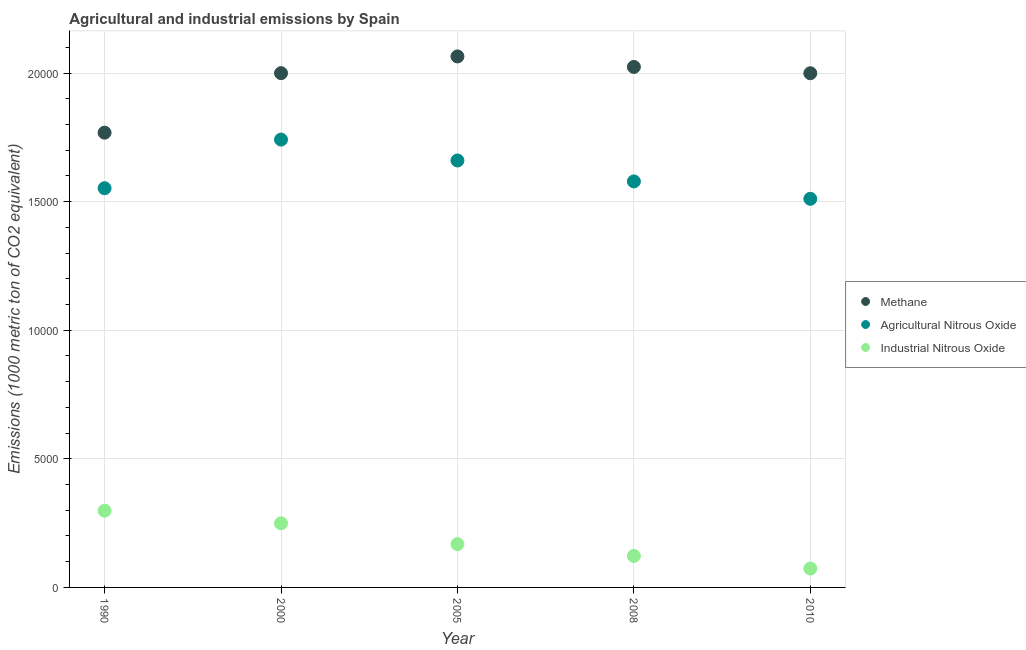How many different coloured dotlines are there?
Your answer should be compact. 3. Is the number of dotlines equal to the number of legend labels?
Your response must be concise. Yes. What is the amount of methane emissions in 2000?
Offer a very short reply. 2.00e+04. Across all years, what is the maximum amount of industrial nitrous oxide emissions?
Make the answer very short. 2982.4. Across all years, what is the minimum amount of agricultural nitrous oxide emissions?
Provide a short and direct response. 1.51e+04. In which year was the amount of agricultural nitrous oxide emissions maximum?
Provide a short and direct response. 2000. What is the total amount of methane emissions in the graph?
Your answer should be compact. 9.86e+04. What is the difference between the amount of agricultural nitrous oxide emissions in 2005 and that in 2010?
Ensure brevity in your answer.  1490. What is the difference between the amount of methane emissions in 2010 and the amount of industrial nitrous oxide emissions in 2008?
Offer a very short reply. 1.88e+04. What is the average amount of agricultural nitrous oxide emissions per year?
Keep it short and to the point. 1.61e+04. In the year 2010, what is the difference between the amount of agricultural nitrous oxide emissions and amount of industrial nitrous oxide emissions?
Provide a succinct answer. 1.44e+04. In how many years, is the amount of agricultural nitrous oxide emissions greater than 10000 metric ton?
Your answer should be compact. 5. What is the ratio of the amount of agricultural nitrous oxide emissions in 2000 to that in 2005?
Provide a succinct answer. 1.05. Is the difference between the amount of agricultural nitrous oxide emissions in 2008 and 2010 greater than the difference between the amount of industrial nitrous oxide emissions in 2008 and 2010?
Provide a short and direct response. Yes. What is the difference between the highest and the second highest amount of methane emissions?
Offer a terse response. 408.9. What is the difference between the highest and the lowest amount of agricultural nitrous oxide emissions?
Ensure brevity in your answer.  2302.5. Does the amount of agricultural nitrous oxide emissions monotonically increase over the years?
Offer a very short reply. No. Is the amount of agricultural nitrous oxide emissions strictly less than the amount of industrial nitrous oxide emissions over the years?
Your answer should be very brief. No. How many dotlines are there?
Give a very brief answer. 3. What is the difference between two consecutive major ticks on the Y-axis?
Offer a terse response. 5000. Are the values on the major ticks of Y-axis written in scientific E-notation?
Make the answer very short. No. Does the graph contain grids?
Give a very brief answer. Yes. How many legend labels are there?
Offer a very short reply. 3. How are the legend labels stacked?
Give a very brief answer. Vertical. What is the title of the graph?
Your response must be concise. Agricultural and industrial emissions by Spain. What is the label or title of the X-axis?
Your answer should be very brief. Year. What is the label or title of the Y-axis?
Your answer should be compact. Emissions (1000 metric ton of CO2 equivalent). What is the Emissions (1000 metric ton of CO2 equivalent) in Methane in 1990?
Your answer should be very brief. 1.77e+04. What is the Emissions (1000 metric ton of CO2 equivalent) of Agricultural Nitrous Oxide in 1990?
Make the answer very short. 1.55e+04. What is the Emissions (1000 metric ton of CO2 equivalent) in Industrial Nitrous Oxide in 1990?
Make the answer very short. 2982.4. What is the Emissions (1000 metric ton of CO2 equivalent) of Methane in 2000?
Your response must be concise. 2.00e+04. What is the Emissions (1000 metric ton of CO2 equivalent) of Agricultural Nitrous Oxide in 2000?
Your answer should be compact. 1.74e+04. What is the Emissions (1000 metric ton of CO2 equivalent) in Industrial Nitrous Oxide in 2000?
Provide a succinct answer. 2493. What is the Emissions (1000 metric ton of CO2 equivalent) in Methane in 2005?
Your answer should be very brief. 2.06e+04. What is the Emissions (1000 metric ton of CO2 equivalent) of Agricultural Nitrous Oxide in 2005?
Offer a terse response. 1.66e+04. What is the Emissions (1000 metric ton of CO2 equivalent) in Industrial Nitrous Oxide in 2005?
Keep it short and to the point. 1685.1. What is the Emissions (1000 metric ton of CO2 equivalent) of Methane in 2008?
Provide a short and direct response. 2.02e+04. What is the Emissions (1000 metric ton of CO2 equivalent) in Agricultural Nitrous Oxide in 2008?
Your answer should be compact. 1.58e+04. What is the Emissions (1000 metric ton of CO2 equivalent) of Industrial Nitrous Oxide in 2008?
Offer a very short reply. 1224.9. What is the Emissions (1000 metric ton of CO2 equivalent) in Methane in 2010?
Give a very brief answer. 2.00e+04. What is the Emissions (1000 metric ton of CO2 equivalent) in Agricultural Nitrous Oxide in 2010?
Give a very brief answer. 1.51e+04. What is the Emissions (1000 metric ton of CO2 equivalent) in Industrial Nitrous Oxide in 2010?
Your answer should be very brief. 734.8. Across all years, what is the maximum Emissions (1000 metric ton of CO2 equivalent) of Methane?
Make the answer very short. 2.06e+04. Across all years, what is the maximum Emissions (1000 metric ton of CO2 equivalent) in Agricultural Nitrous Oxide?
Your answer should be very brief. 1.74e+04. Across all years, what is the maximum Emissions (1000 metric ton of CO2 equivalent) of Industrial Nitrous Oxide?
Provide a succinct answer. 2982.4. Across all years, what is the minimum Emissions (1000 metric ton of CO2 equivalent) of Methane?
Provide a succinct answer. 1.77e+04. Across all years, what is the minimum Emissions (1000 metric ton of CO2 equivalent) in Agricultural Nitrous Oxide?
Provide a succinct answer. 1.51e+04. Across all years, what is the minimum Emissions (1000 metric ton of CO2 equivalent) of Industrial Nitrous Oxide?
Offer a terse response. 734.8. What is the total Emissions (1000 metric ton of CO2 equivalent) of Methane in the graph?
Ensure brevity in your answer.  9.86e+04. What is the total Emissions (1000 metric ton of CO2 equivalent) in Agricultural Nitrous Oxide in the graph?
Your answer should be compact. 8.04e+04. What is the total Emissions (1000 metric ton of CO2 equivalent) of Industrial Nitrous Oxide in the graph?
Your answer should be compact. 9120.2. What is the difference between the Emissions (1000 metric ton of CO2 equivalent) in Methane in 1990 and that in 2000?
Make the answer very short. -2314.1. What is the difference between the Emissions (1000 metric ton of CO2 equivalent) in Agricultural Nitrous Oxide in 1990 and that in 2000?
Make the answer very short. -1890.8. What is the difference between the Emissions (1000 metric ton of CO2 equivalent) in Industrial Nitrous Oxide in 1990 and that in 2000?
Make the answer very short. 489.4. What is the difference between the Emissions (1000 metric ton of CO2 equivalent) of Methane in 1990 and that in 2005?
Provide a succinct answer. -2964.8. What is the difference between the Emissions (1000 metric ton of CO2 equivalent) of Agricultural Nitrous Oxide in 1990 and that in 2005?
Your response must be concise. -1078.3. What is the difference between the Emissions (1000 metric ton of CO2 equivalent) in Industrial Nitrous Oxide in 1990 and that in 2005?
Provide a short and direct response. 1297.3. What is the difference between the Emissions (1000 metric ton of CO2 equivalent) in Methane in 1990 and that in 2008?
Make the answer very short. -2555.9. What is the difference between the Emissions (1000 metric ton of CO2 equivalent) of Agricultural Nitrous Oxide in 1990 and that in 2008?
Your answer should be very brief. -264.1. What is the difference between the Emissions (1000 metric ton of CO2 equivalent) in Industrial Nitrous Oxide in 1990 and that in 2008?
Keep it short and to the point. 1757.5. What is the difference between the Emissions (1000 metric ton of CO2 equivalent) in Methane in 1990 and that in 2010?
Make the answer very short. -2311. What is the difference between the Emissions (1000 metric ton of CO2 equivalent) in Agricultural Nitrous Oxide in 1990 and that in 2010?
Provide a short and direct response. 411.7. What is the difference between the Emissions (1000 metric ton of CO2 equivalent) of Industrial Nitrous Oxide in 1990 and that in 2010?
Offer a terse response. 2247.6. What is the difference between the Emissions (1000 metric ton of CO2 equivalent) of Methane in 2000 and that in 2005?
Keep it short and to the point. -650.7. What is the difference between the Emissions (1000 metric ton of CO2 equivalent) of Agricultural Nitrous Oxide in 2000 and that in 2005?
Offer a very short reply. 812.5. What is the difference between the Emissions (1000 metric ton of CO2 equivalent) in Industrial Nitrous Oxide in 2000 and that in 2005?
Provide a short and direct response. 807.9. What is the difference between the Emissions (1000 metric ton of CO2 equivalent) of Methane in 2000 and that in 2008?
Make the answer very short. -241.8. What is the difference between the Emissions (1000 metric ton of CO2 equivalent) in Agricultural Nitrous Oxide in 2000 and that in 2008?
Ensure brevity in your answer.  1626.7. What is the difference between the Emissions (1000 metric ton of CO2 equivalent) in Industrial Nitrous Oxide in 2000 and that in 2008?
Provide a succinct answer. 1268.1. What is the difference between the Emissions (1000 metric ton of CO2 equivalent) of Agricultural Nitrous Oxide in 2000 and that in 2010?
Offer a terse response. 2302.5. What is the difference between the Emissions (1000 metric ton of CO2 equivalent) of Industrial Nitrous Oxide in 2000 and that in 2010?
Provide a short and direct response. 1758.2. What is the difference between the Emissions (1000 metric ton of CO2 equivalent) of Methane in 2005 and that in 2008?
Your answer should be very brief. 408.9. What is the difference between the Emissions (1000 metric ton of CO2 equivalent) of Agricultural Nitrous Oxide in 2005 and that in 2008?
Ensure brevity in your answer.  814.2. What is the difference between the Emissions (1000 metric ton of CO2 equivalent) in Industrial Nitrous Oxide in 2005 and that in 2008?
Give a very brief answer. 460.2. What is the difference between the Emissions (1000 metric ton of CO2 equivalent) of Methane in 2005 and that in 2010?
Provide a short and direct response. 653.8. What is the difference between the Emissions (1000 metric ton of CO2 equivalent) in Agricultural Nitrous Oxide in 2005 and that in 2010?
Your answer should be compact. 1490. What is the difference between the Emissions (1000 metric ton of CO2 equivalent) of Industrial Nitrous Oxide in 2005 and that in 2010?
Offer a terse response. 950.3. What is the difference between the Emissions (1000 metric ton of CO2 equivalent) in Methane in 2008 and that in 2010?
Provide a short and direct response. 244.9. What is the difference between the Emissions (1000 metric ton of CO2 equivalent) in Agricultural Nitrous Oxide in 2008 and that in 2010?
Make the answer very short. 675.8. What is the difference between the Emissions (1000 metric ton of CO2 equivalent) of Industrial Nitrous Oxide in 2008 and that in 2010?
Ensure brevity in your answer.  490.1. What is the difference between the Emissions (1000 metric ton of CO2 equivalent) in Methane in 1990 and the Emissions (1000 metric ton of CO2 equivalent) in Agricultural Nitrous Oxide in 2000?
Your answer should be very brief. 268.8. What is the difference between the Emissions (1000 metric ton of CO2 equivalent) of Methane in 1990 and the Emissions (1000 metric ton of CO2 equivalent) of Industrial Nitrous Oxide in 2000?
Make the answer very short. 1.52e+04. What is the difference between the Emissions (1000 metric ton of CO2 equivalent) in Agricultural Nitrous Oxide in 1990 and the Emissions (1000 metric ton of CO2 equivalent) in Industrial Nitrous Oxide in 2000?
Provide a succinct answer. 1.30e+04. What is the difference between the Emissions (1000 metric ton of CO2 equivalent) in Methane in 1990 and the Emissions (1000 metric ton of CO2 equivalent) in Agricultural Nitrous Oxide in 2005?
Your response must be concise. 1081.3. What is the difference between the Emissions (1000 metric ton of CO2 equivalent) in Methane in 1990 and the Emissions (1000 metric ton of CO2 equivalent) in Industrial Nitrous Oxide in 2005?
Ensure brevity in your answer.  1.60e+04. What is the difference between the Emissions (1000 metric ton of CO2 equivalent) in Agricultural Nitrous Oxide in 1990 and the Emissions (1000 metric ton of CO2 equivalent) in Industrial Nitrous Oxide in 2005?
Keep it short and to the point. 1.38e+04. What is the difference between the Emissions (1000 metric ton of CO2 equivalent) in Methane in 1990 and the Emissions (1000 metric ton of CO2 equivalent) in Agricultural Nitrous Oxide in 2008?
Offer a terse response. 1895.5. What is the difference between the Emissions (1000 metric ton of CO2 equivalent) of Methane in 1990 and the Emissions (1000 metric ton of CO2 equivalent) of Industrial Nitrous Oxide in 2008?
Keep it short and to the point. 1.65e+04. What is the difference between the Emissions (1000 metric ton of CO2 equivalent) in Agricultural Nitrous Oxide in 1990 and the Emissions (1000 metric ton of CO2 equivalent) in Industrial Nitrous Oxide in 2008?
Keep it short and to the point. 1.43e+04. What is the difference between the Emissions (1000 metric ton of CO2 equivalent) in Methane in 1990 and the Emissions (1000 metric ton of CO2 equivalent) in Agricultural Nitrous Oxide in 2010?
Provide a succinct answer. 2571.3. What is the difference between the Emissions (1000 metric ton of CO2 equivalent) of Methane in 1990 and the Emissions (1000 metric ton of CO2 equivalent) of Industrial Nitrous Oxide in 2010?
Ensure brevity in your answer.  1.69e+04. What is the difference between the Emissions (1000 metric ton of CO2 equivalent) of Agricultural Nitrous Oxide in 1990 and the Emissions (1000 metric ton of CO2 equivalent) of Industrial Nitrous Oxide in 2010?
Make the answer very short. 1.48e+04. What is the difference between the Emissions (1000 metric ton of CO2 equivalent) of Methane in 2000 and the Emissions (1000 metric ton of CO2 equivalent) of Agricultural Nitrous Oxide in 2005?
Offer a terse response. 3395.4. What is the difference between the Emissions (1000 metric ton of CO2 equivalent) in Methane in 2000 and the Emissions (1000 metric ton of CO2 equivalent) in Industrial Nitrous Oxide in 2005?
Offer a terse response. 1.83e+04. What is the difference between the Emissions (1000 metric ton of CO2 equivalent) in Agricultural Nitrous Oxide in 2000 and the Emissions (1000 metric ton of CO2 equivalent) in Industrial Nitrous Oxide in 2005?
Your response must be concise. 1.57e+04. What is the difference between the Emissions (1000 metric ton of CO2 equivalent) in Methane in 2000 and the Emissions (1000 metric ton of CO2 equivalent) in Agricultural Nitrous Oxide in 2008?
Provide a short and direct response. 4209.6. What is the difference between the Emissions (1000 metric ton of CO2 equivalent) of Methane in 2000 and the Emissions (1000 metric ton of CO2 equivalent) of Industrial Nitrous Oxide in 2008?
Provide a succinct answer. 1.88e+04. What is the difference between the Emissions (1000 metric ton of CO2 equivalent) of Agricultural Nitrous Oxide in 2000 and the Emissions (1000 metric ton of CO2 equivalent) of Industrial Nitrous Oxide in 2008?
Keep it short and to the point. 1.62e+04. What is the difference between the Emissions (1000 metric ton of CO2 equivalent) of Methane in 2000 and the Emissions (1000 metric ton of CO2 equivalent) of Agricultural Nitrous Oxide in 2010?
Offer a terse response. 4885.4. What is the difference between the Emissions (1000 metric ton of CO2 equivalent) of Methane in 2000 and the Emissions (1000 metric ton of CO2 equivalent) of Industrial Nitrous Oxide in 2010?
Offer a very short reply. 1.93e+04. What is the difference between the Emissions (1000 metric ton of CO2 equivalent) in Agricultural Nitrous Oxide in 2000 and the Emissions (1000 metric ton of CO2 equivalent) in Industrial Nitrous Oxide in 2010?
Your answer should be compact. 1.67e+04. What is the difference between the Emissions (1000 metric ton of CO2 equivalent) of Methane in 2005 and the Emissions (1000 metric ton of CO2 equivalent) of Agricultural Nitrous Oxide in 2008?
Provide a succinct answer. 4860.3. What is the difference between the Emissions (1000 metric ton of CO2 equivalent) in Methane in 2005 and the Emissions (1000 metric ton of CO2 equivalent) in Industrial Nitrous Oxide in 2008?
Keep it short and to the point. 1.94e+04. What is the difference between the Emissions (1000 metric ton of CO2 equivalent) of Agricultural Nitrous Oxide in 2005 and the Emissions (1000 metric ton of CO2 equivalent) of Industrial Nitrous Oxide in 2008?
Offer a very short reply. 1.54e+04. What is the difference between the Emissions (1000 metric ton of CO2 equivalent) of Methane in 2005 and the Emissions (1000 metric ton of CO2 equivalent) of Agricultural Nitrous Oxide in 2010?
Make the answer very short. 5536.1. What is the difference between the Emissions (1000 metric ton of CO2 equivalent) of Methane in 2005 and the Emissions (1000 metric ton of CO2 equivalent) of Industrial Nitrous Oxide in 2010?
Offer a terse response. 1.99e+04. What is the difference between the Emissions (1000 metric ton of CO2 equivalent) of Agricultural Nitrous Oxide in 2005 and the Emissions (1000 metric ton of CO2 equivalent) of Industrial Nitrous Oxide in 2010?
Keep it short and to the point. 1.59e+04. What is the difference between the Emissions (1000 metric ton of CO2 equivalent) in Methane in 2008 and the Emissions (1000 metric ton of CO2 equivalent) in Agricultural Nitrous Oxide in 2010?
Your answer should be compact. 5127.2. What is the difference between the Emissions (1000 metric ton of CO2 equivalent) of Methane in 2008 and the Emissions (1000 metric ton of CO2 equivalent) of Industrial Nitrous Oxide in 2010?
Give a very brief answer. 1.95e+04. What is the difference between the Emissions (1000 metric ton of CO2 equivalent) of Agricultural Nitrous Oxide in 2008 and the Emissions (1000 metric ton of CO2 equivalent) of Industrial Nitrous Oxide in 2010?
Provide a succinct answer. 1.51e+04. What is the average Emissions (1000 metric ton of CO2 equivalent) of Methane per year?
Provide a succinct answer. 1.97e+04. What is the average Emissions (1000 metric ton of CO2 equivalent) in Agricultural Nitrous Oxide per year?
Ensure brevity in your answer.  1.61e+04. What is the average Emissions (1000 metric ton of CO2 equivalent) in Industrial Nitrous Oxide per year?
Offer a terse response. 1824.04. In the year 1990, what is the difference between the Emissions (1000 metric ton of CO2 equivalent) of Methane and Emissions (1000 metric ton of CO2 equivalent) of Agricultural Nitrous Oxide?
Ensure brevity in your answer.  2159.6. In the year 1990, what is the difference between the Emissions (1000 metric ton of CO2 equivalent) of Methane and Emissions (1000 metric ton of CO2 equivalent) of Industrial Nitrous Oxide?
Make the answer very short. 1.47e+04. In the year 1990, what is the difference between the Emissions (1000 metric ton of CO2 equivalent) of Agricultural Nitrous Oxide and Emissions (1000 metric ton of CO2 equivalent) of Industrial Nitrous Oxide?
Make the answer very short. 1.25e+04. In the year 2000, what is the difference between the Emissions (1000 metric ton of CO2 equivalent) in Methane and Emissions (1000 metric ton of CO2 equivalent) in Agricultural Nitrous Oxide?
Your answer should be compact. 2582.9. In the year 2000, what is the difference between the Emissions (1000 metric ton of CO2 equivalent) of Methane and Emissions (1000 metric ton of CO2 equivalent) of Industrial Nitrous Oxide?
Ensure brevity in your answer.  1.75e+04. In the year 2000, what is the difference between the Emissions (1000 metric ton of CO2 equivalent) of Agricultural Nitrous Oxide and Emissions (1000 metric ton of CO2 equivalent) of Industrial Nitrous Oxide?
Keep it short and to the point. 1.49e+04. In the year 2005, what is the difference between the Emissions (1000 metric ton of CO2 equivalent) of Methane and Emissions (1000 metric ton of CO2 equivalent) of Agricultural Nitrous Oxide?
Provide a succinct answer. 4046.1. In the year 2005, what is the difference between the Emissions (1000 metric ton of CO2 equivalent) of Methane and Emissions (1000 metric ton of CO2 equivalent) of Industrial Nitrous Oxide?
Ensure brevity in your answer.  1.90e+04. In the year 2005, what is the difference between the Emissions (1000 metric ton of CO2 equivalent) in Agricultural Nitrous Oxide and Emissions (1000 metric ton of CO2 equivalent) in Industrial Nitrous Oxide?
Ensure brevity in your answer.  1.49e+04. In the year 2008, what is the difference between the Emissions (1000 metric ton of CO2 equivalent) in Methane and Emissions (1000 metric ton of CO2 equivalent) in Agricultural Nitrous Oxide?
Provide a short and direct response. 4451.4. In the year 2008, what is the difference between the Emissions (1000 metric ton of CO2 equivalent) of Methane and Emissions (1000 metric ton of CO2 equivalent) of Industrial Nitrous Oxide?
Provide a short and direct response. 1.90e+04. In the year 2008, what is the difference between the Emissions (1000 metric ton of CO2 equivalent) of Agricultural Nitrous Oxide and Emissions (1000 metric ton of CO2 equivalent) of Industrial Nitrous Oxide?
Your answer should be compact. 1.46e+04. In the year 2010, what is the difference between the Emissions (1000 metric ton of CO2 equivalent) in Methane and Emissions (1000 metric ton of CO2 equivalent) in Agricultural Nitrous Oxide?
Give a very brief answer. 4882.3. In the year 2010, what is the difference between the Emissions (1000 metric ton of CO2 equivalent) of Methane and Emissions (1000 metric ton of CO2 equivalent) of Industrial Nitrous Oxide?
Offer a very short reply. 1.93e+04. In the year 2010, what is the difference between the Emissions (1000 metric ton of CO2 equivalent) of Agricultural Nitrous Oxide and Emissions (1000 metric ton of CO2 equivalent) of Industrial Nitrous Oxide?
Offer a terse response. 1.44e+04. What is the ratio of the Emissions (1000 metric ton of CO2 equivalent) of Methane in 1990 to that in 2000?
Provide a succinct answer. 0.88. What is the ratio of the Emissions (1000 metric ton of CO2 equivalent) in Agricultural Nitrous Oxide in 1990 to that in 2000?
Your response must be concise. 0.89. What is the ratio of the Emissions (1000 metric ton of CO2 equivalent) in Industrial Nitrous Oxide in 1990 to that in 2000?
Ensure brevity in your answer.  1.2. What is the ratio of the Emissions (1000 metric ton of CO2 equivalent) in Methane in 1990 to that in 2005?
Your response must be concise. 0.86. What is the ratio of the Emissions (1000 metric ton of CO2 equivalent) of Agricultural Nitrous Oxide in 1990 to that in 2005?
Ensure brevity in your answer.  0.94. What is the ratio of the Emissions (1000 metric ton of CO2 equivalent) in Industrial Nitrous Oxide in 1990 to that in 2005?
Offer a very short reply. 1.77. What is the ratio of the Emissions (1000 metric ton of CO2 equivalent) of Methane in 1990 to that in 2008?
Your answer should be very brief. 0.87. What is the ratio of the Emissions (1000 metric ton of CO2 equivalent) in Agricultural Nitrous Oxide in 1990 to that in 2008?
Offer a very short reply. 0.98. What is the ratio of the Emissions (1000 metric ton of CO2 equivalent) in Industrial Nitrous Oxide in 1990 to that in 2008?
Your answer should be very brief. 2.43. What is the ratio of the Emissions (1000 metric ton of CO2 equivalent) in Methane in 1990 to that in 2010?
Provide a succinct answer. 0.88. What is the ratio of the Emissions (1000 metric ton of CO2 equivalent) in Agricultural Nitrous Oxide in 1990 to that in 2010?
Provide a short and direct response. 1.03. What is the ratio of the Emissions (1000 metric ton of CO2 equivalent) of Industrial Nitrous Oxide in 1990 to that in 2010?
Keep it short and to the point. 4.06. What is the ratio of the Emissions (1000 metric ton of CO2 equivalent) of Methane in 2000 to that in 2005?
Your answer should be compact. 0.97. What is the ratio of the Emissions (1000 metric ton of CO2 equivalent) in Agricultural Nitrous Oxide in 2000 to that in 2005?
Keep it short and to the point. 1.05. What is the ratio of the Emissions (1000 metric ton of CO2 equivalent) of Industrial Nitrous Oxide in 2000 to that in 2005?
Keep it short and to the point. 1.48. What is the ratio of the Emissions (1000 metric ton of CO2 equivalent) of Methane in 2000 to that in 2008?
Your answer should be very brief. 0.99. What is the ratio of the Emissions (1000 metric ton of CO2 equivalent) in Agricultural Nitrous Oxide in 2000 to that in 2008?
Your answer should be very brief. 1.1. What is the ratio of the Emissions (1000 metric ton of CO2 equivalent) of Industrial Nitrous Oxide in 2000 to that in 2008?
Your response must be concise. 2.04. What is the ratio of the Emissions (1000 metric ton of CO2 equivalent) of Methane in 2000 to that in 2010?
Your response must be concise. 1. What is the ratio of the Emissions (1000 metric ton of CO2 equivalent) in Agricultural Nitrous Oxide in 2000 to that in 2010?
Keep it short and to the point. 1.15. What is the ratio of the Emissions (1000 metric ton of CO2 equivalent) in Industrial Nitrous Oxide in 2000 to that in 2010?
Give a very brief answer. 3.39. What is the ratio of the Emissions (1000 metric ton of CO2 equivalent) in Methane in 2005 to that in 2008?
Ensure brevity in your answer.  1.02. What is the ratio of the Emissions (1000 metric ton of CO2 equivalent) in Agricultural Nitrous Oxide in 2005 to that in 2008?
Provide a succinct answer. 1.05. What is the ratio of the Emissions (1000 metric ton of CO2 equivalent) of Industrial Nitrous Oxide in 2005 to that in 2008?
Your answer should be very brief. 1.38. What is the ratio of the Emissions (1000 metric ton of CO2 equivalent) of Methane in 2005 to that in 2010?
Make the answer very short. 1.03. What is the ratio of the Emissions (1000 metric ton of CO2 equivalent) in Agricultural Nitrous Oxide in 2005 to that in 2010?
Provide a short and direct response. 1.1. What is the ratio of the Emissions (1000 metric ton of CO2 equivalent) in Industrial Nitrous Oxide in 2005 to that in 2010?
Ensure brevity in your answer.  2.29. What is the ratio of the Emissions (1000 metric ton of CO2 equivalent) of Methane in 2008 to that in 2010?
Your response must be concise. 1.01. What is the ratio of the Emissions (1000 metric ton of CO2 equivalent) in Agricultural Nitrous Oxide in 2008 to that in 2010?
Give a very brief answer. 1.04. What is the ratio of the Emissions (1000 metric ton of CO2 equivalent) in Industrial Nitrous Oxide in 2008 to that in 2010?
Provide a succinct answer. 1.67. What is the difference between the highest and the second highest Emissions (1000 metric ton of CO2 equivalent) in Methane?
Offer a very short reply. 408.9. What is the difference between the highest and the second highest Emissions (1000 metric ton of CO2 equivalent) in Agricultural Nitrous Oxide?
Offer a very short reply. 812.5. What is the difference between the highest and the second highest Emissions (1000 metric ton of CO2 equivalent) in Industrial Nitrous Oxide?
Your answer should be compact. 489.4. What is the difference between the highest and the lowest Emissions (1000 metric ton of CO2 equivalent) in Methane?
Give a very brief answer. 2964.8. What is the difference between the highest and the lowest Emissions (1000 metric ton of CO2 equivalent) of Agricultural Nitrous Oxide?
Your response must be concise. 2302.5. What is the difference between the highest and the lowest Emissions (1000 metric ton of CO2 equivalent) of Industrial Nitrous Oxide?
Your response must be concise. 2247.6. 